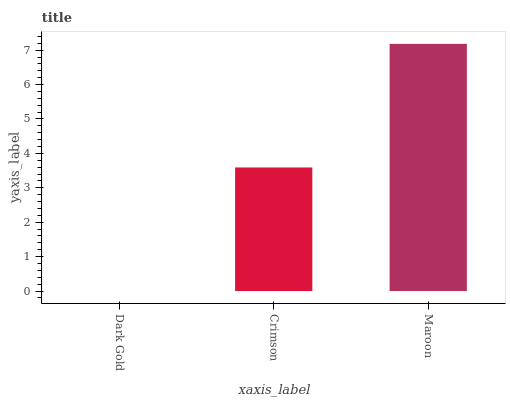Is Dark Gold the minimum?
Answer yes or no. Yes. Is Maroon the maximum?
Answer yes or no. Yes. Is Crimson the minimum?
Answer yes or no. No. Is Crimson the maximum?
Answer yes or no. No. Is Crimson greater than Dark Gold?
Answer yes or no. Yes. Is Dark Gold less than Crimson?
Answer yes or no. Yes. Is Dark Gold greater than Crimson?
Answer yes or no. No. Is Crimson less than Dark Gold?
Answer yes or no. No. Is Crimson the high median?
Answer yes or no. Yes. Is Crimson the low median?
Answer yes or no. Yes. Is Maroon the high median?
Answer yes or no. No. Is Maroon the low median?
Answer yes or no. No. 